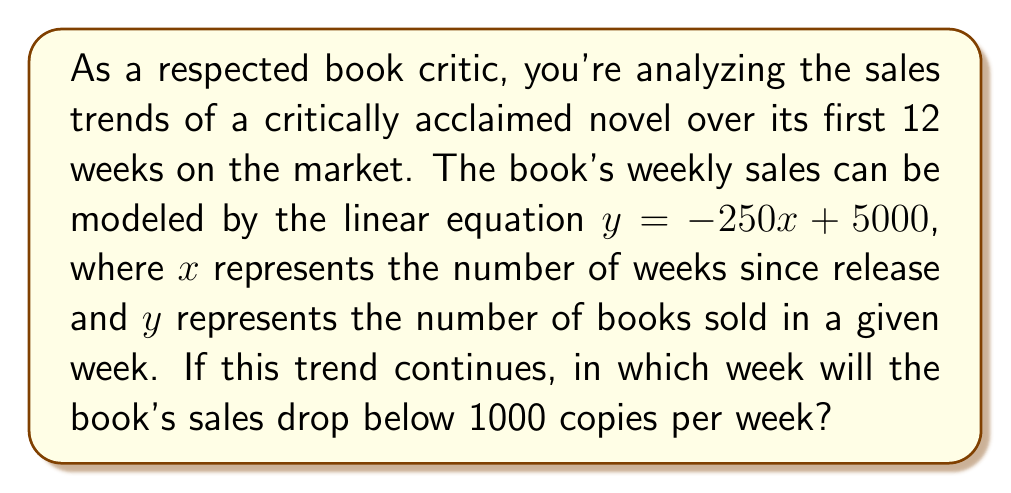Give your solution to this math problem. To solve this problem, we need to follow these steps:

1) The given linear equation is $y = -250x + 5000$, where:
   $y$ = number of books sold in a week
   $x$ = number of weeks since release

2) We want to find when $y < 1000$. So, let's set up the inequality:
   $-250x + 5000 < 1000$

3) Solve the inequality:
   $-250x < -4000$
   $250x > 4000$
   $x > 16$

4) Since $x$ represents weeks and must be a whole number, we need to round up to the next integer.

5) Therefore, in the 17th week, the sales will drop below 1000 copies.

To verify:
For week 16: $y = -250(16) + 5000 = 1000$
For week 17: $y = -250(17) + 5000 = 750$

This confirms that week 17 is the first week where sales drop below 1000 copies.
Answer: Week 17 